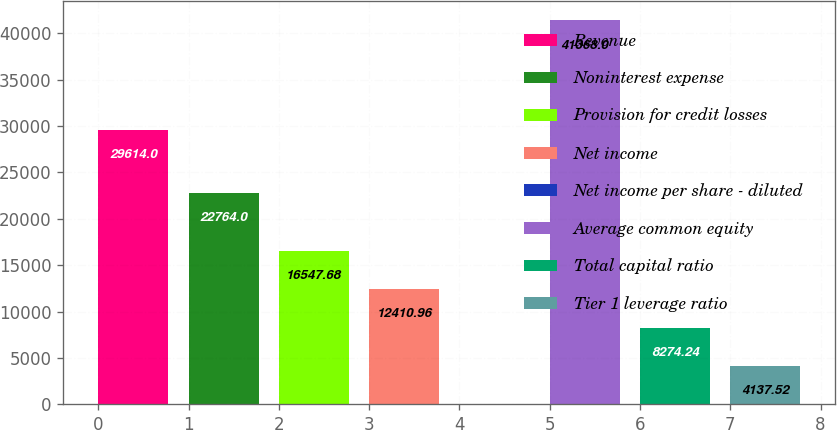<chart> <loc_0><loc_0><loc_500><loc_500><bar_chart><fcel>Revenue<fcel>Noninterest expense<fcel>Provision for credit losses<fcel>Net income<fcel>Net income per share - diluted<fcel>Average common equity<fcel>Total capital ratio<fcel>Tier 1 leverage ratio<nl><fcel>29614<fcel>22764<fcel>16547.7<fcel>12411<fcel>0.8<fcel>41368<fcel>8274.24<fcel>4137.52<nl></chart> 